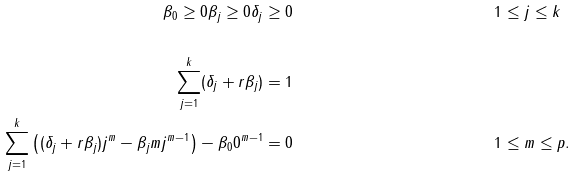Convert formula to latex. <formula><loc_0><loc_0><loc_500><loc_500>\\ \beta _ { 0 } \geq 0 \beta _ { j } \geq 0 \delta _ { j } & \geq 0 & & 1 \leq j \leq k \\ \\ \sum _ { j = 1 } ^ { k } ( \delta _ { j } + r \beta _ { j } ) & = 1 & & \\ \sum _ { j = 1 } ^ { k } \left ( ( \delta _ { j } + r \beta _ { j } ) j ^ { m } - \beta _ { j } m j ^ { m - 1 } \right ) - \beta _ { 0 } 0 ^ { m - 1 } & = 0 & & 1 \leq m \leq p .</formula> 